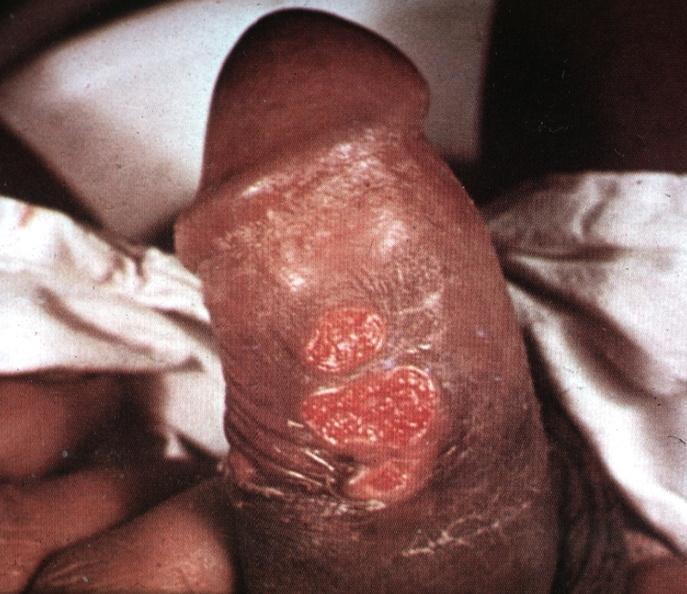s bread-loaf slices into prostate gland present?
Answer the question using a single word or phrase. No 